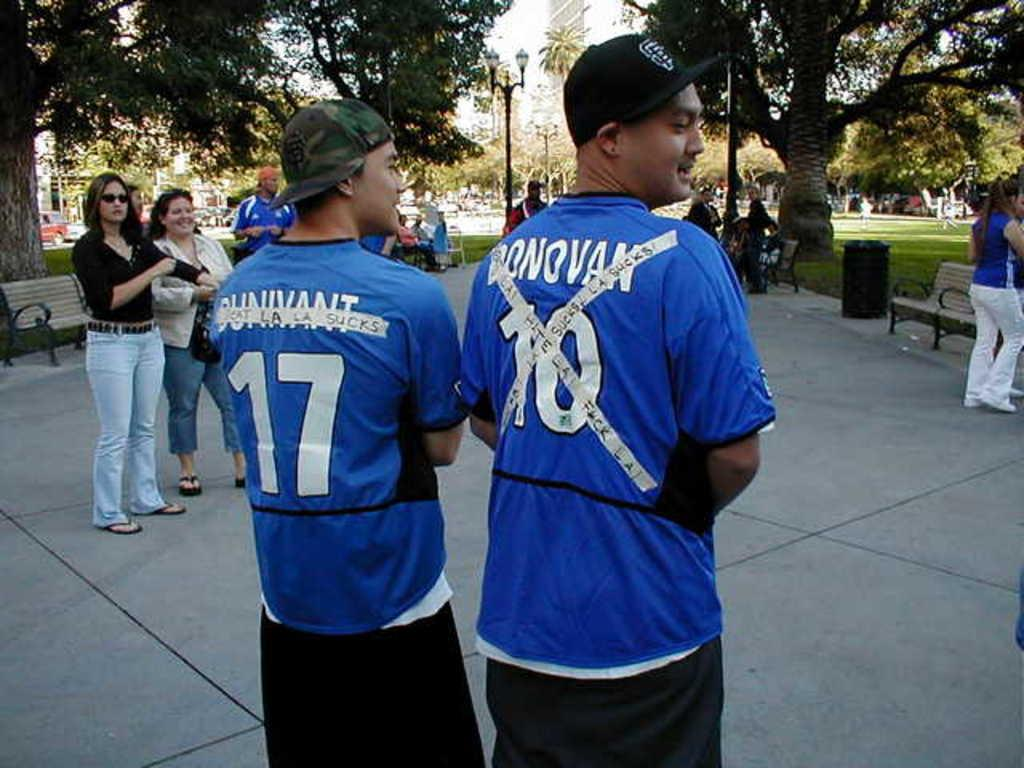<image>
Write a terse but informative summary of the picture. Two guys wear blue shirts with number 17 on the left and number 10 on the right. 